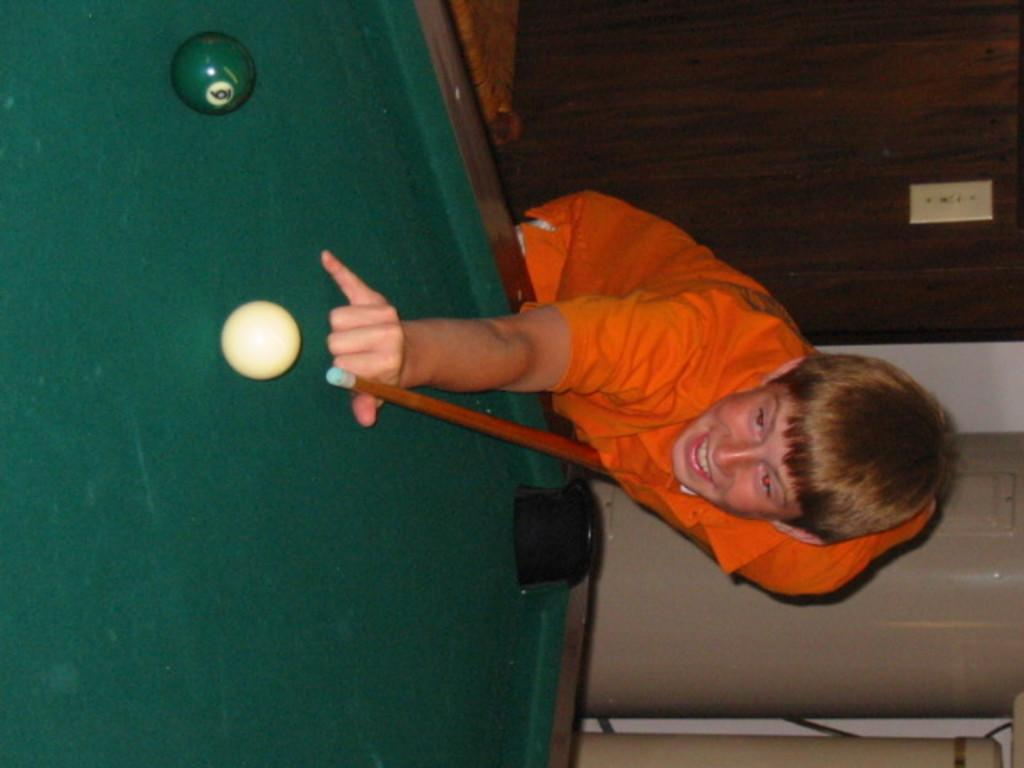Who is present in the image? There is a boy in the image. What is the boy doing in the image? The boy is hitting a ball with a stick on a table. What is the boy's facial expression in the image? The boy is smiling in the image. What can be seen in the background of the image? There is a wall and a door in the background of the image. Can you tell me how many steps the boy is taking in the image? There is no indication of the boy walking or taking steps in the image; he is hitting a ball with a stick on a table. What type of mine is visible in the background of the image? There is no mine present in the image; the background features a wall and a door. 